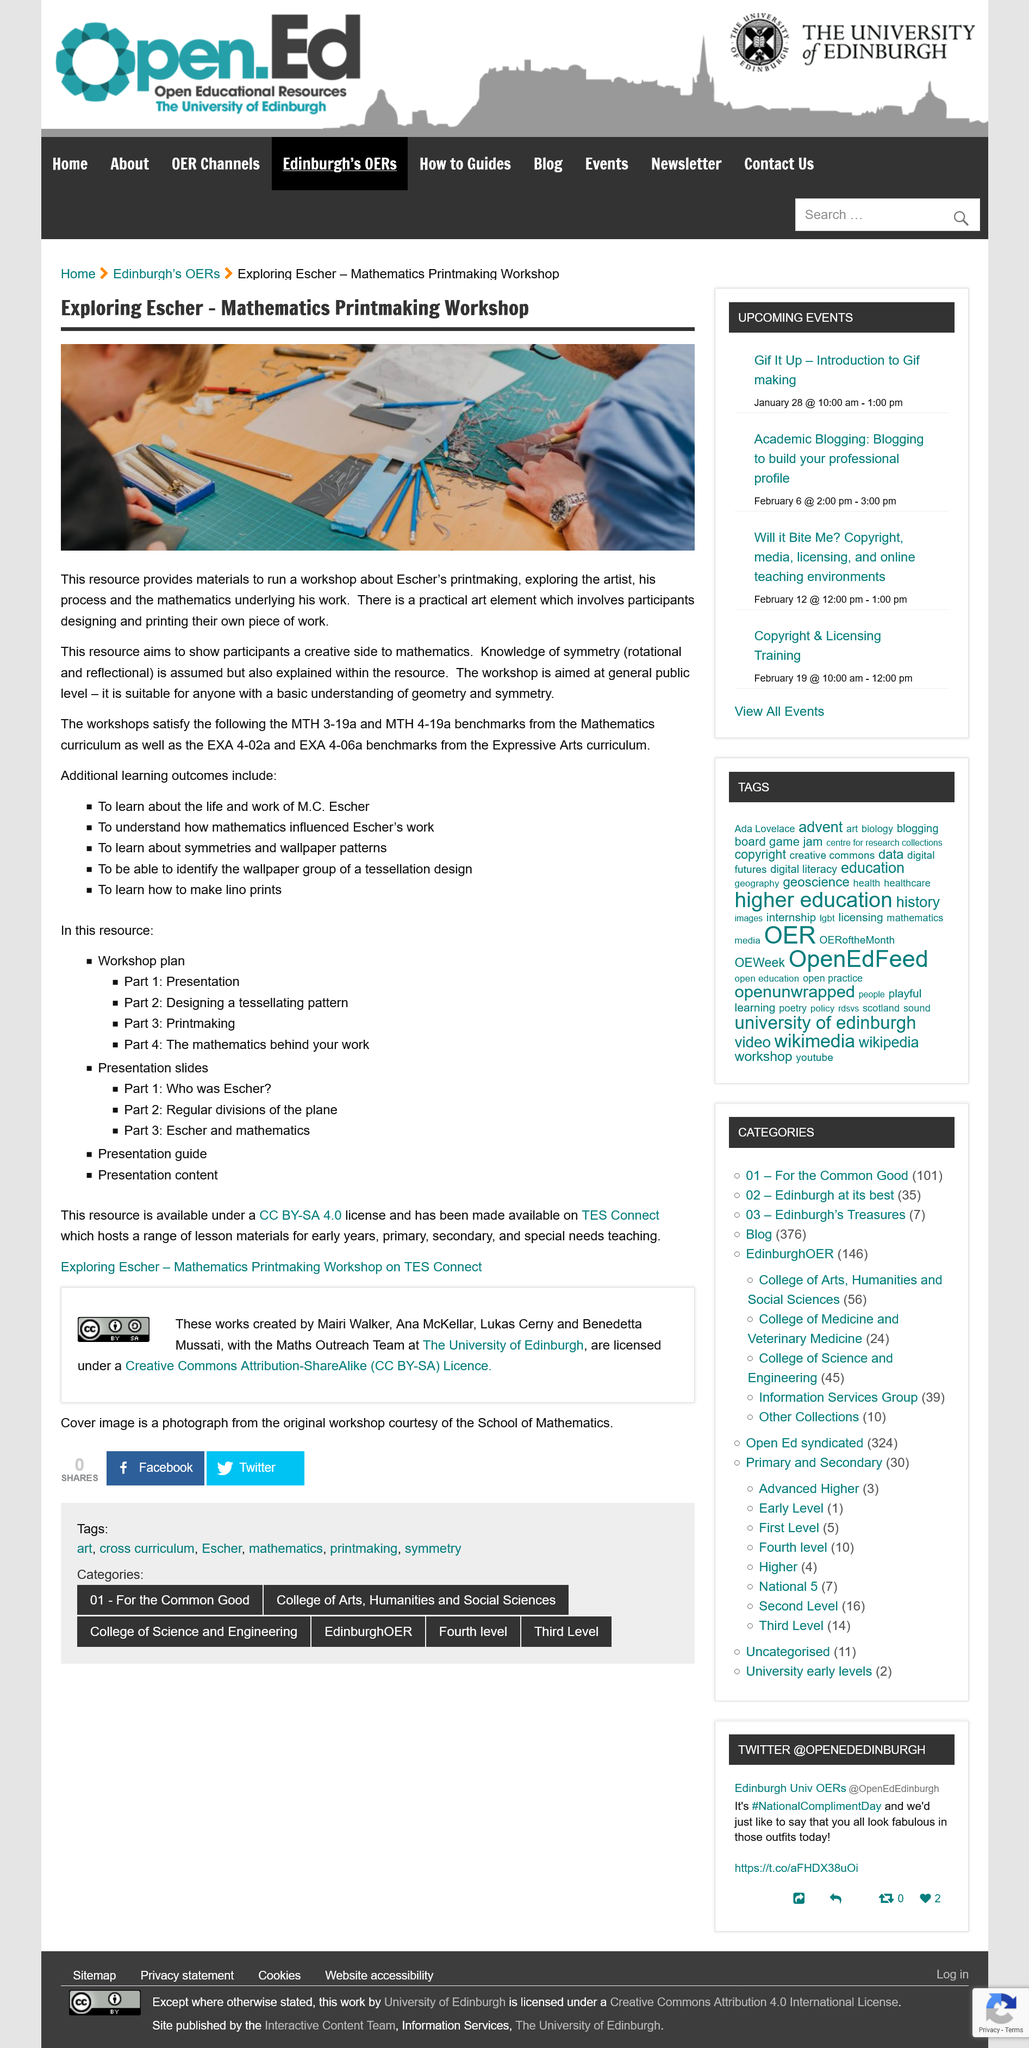Draw attention to some important aspects in this diagram. The workshop enables participants to craft their own original pieces. This workshop is designed for individuals with a foundational understanding of geometry and symmetry, seeking to expand their knowledge and skills in these areas. The photograph displays two individuals. 